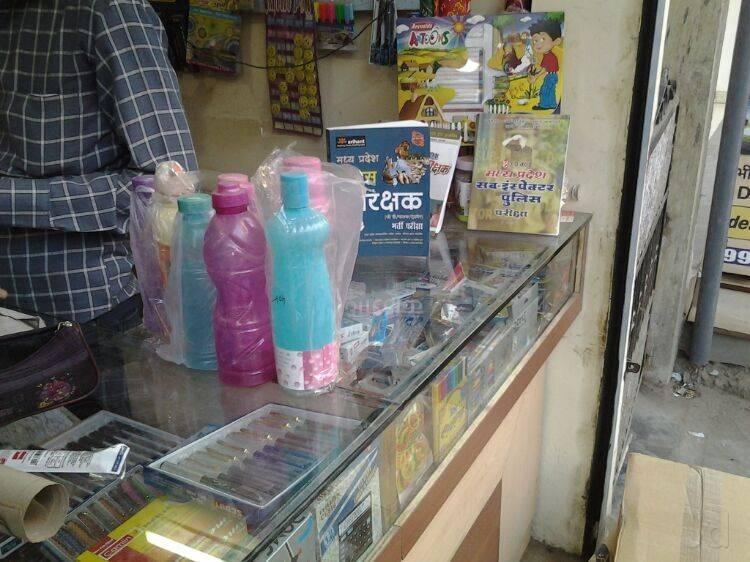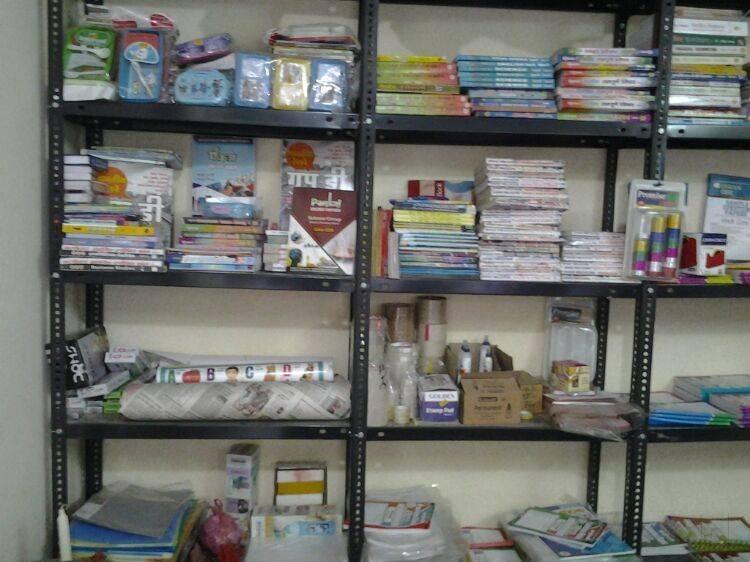The first image is the image on the left, the second image is the image on the right. Given the left and right images, does the statement "There are three men with black hair and brown skin inside a bookstore." hold true? Answer yes or no. No. 